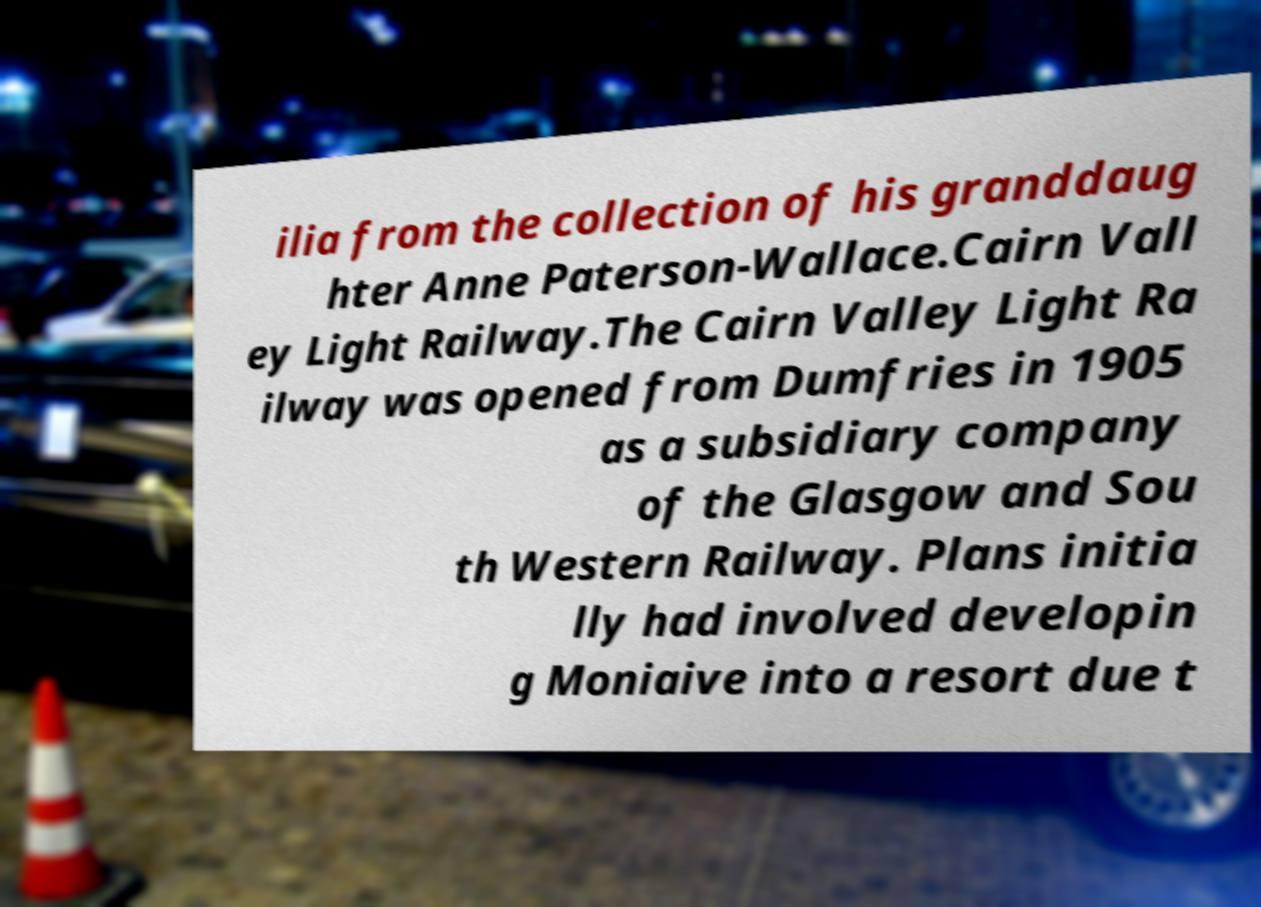I need the written content from this picture converted into text. Can you do that? ilia from the collection of his granddaug hter Anne Paterson-Wallace.Cairn Vall ey Light Railway.The Cairn Valley Light Ra ilway was opened from Dumfries in 1905 as a subsidiary company of the Glasgow and Sou th Western Railway. Plans initia lly had involved developin g Moniaive into a resort due t 